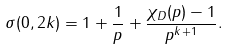<formula> <loc_0><loc_0><loc_500><loc_500>\sigma ( 0 , 2 k ) = 1 + \frac { 1 } { p } + \frac { \chi _ { D } ( p ) - 1 } { p ^ { k + 1 } } .</formula> 